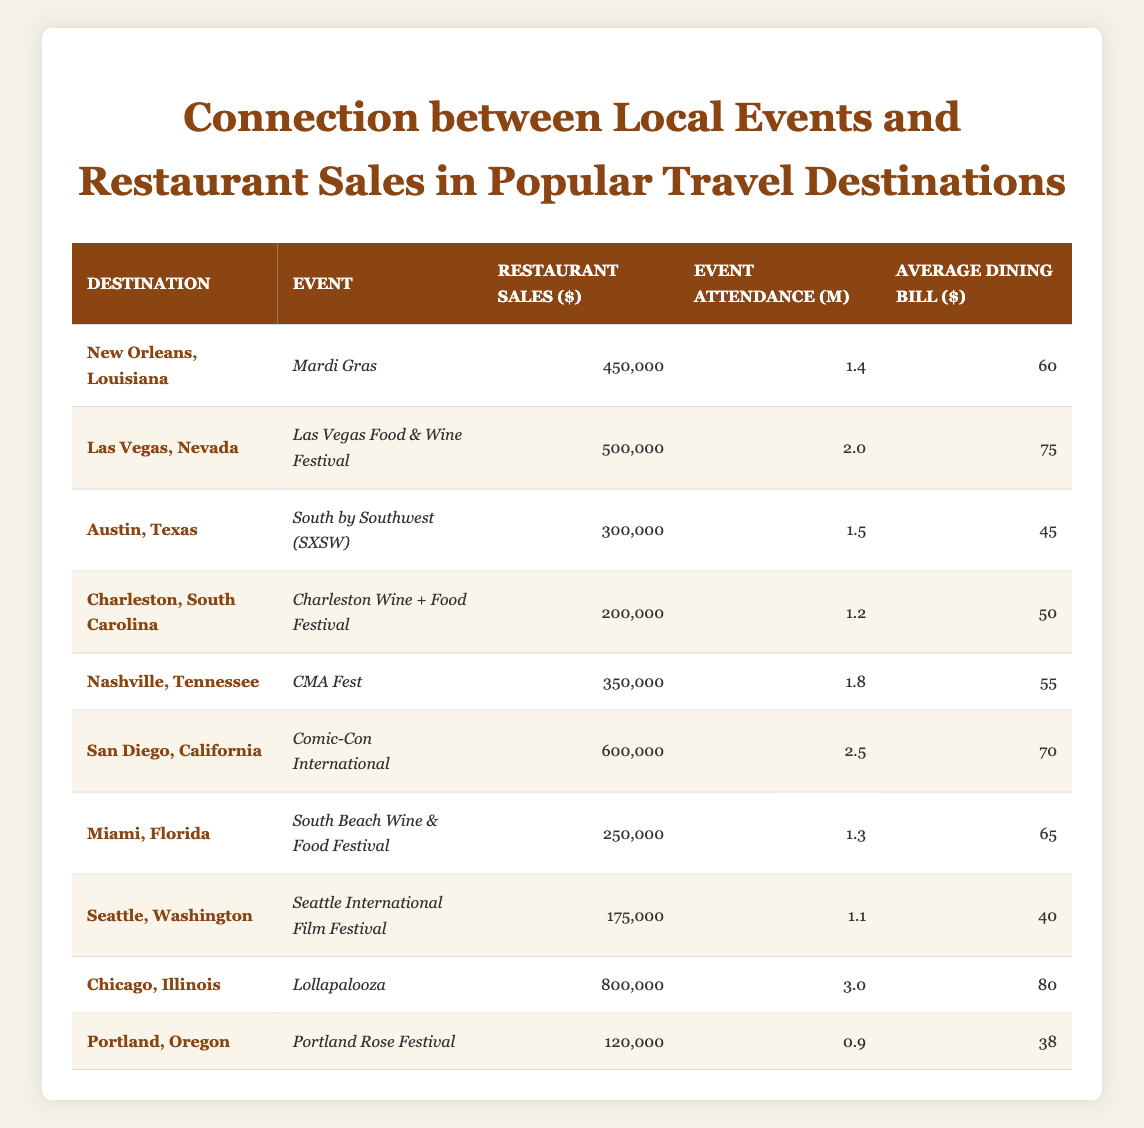What is the highest restaurant sales recorded in the table? By looking at the "Restaurant Sales ($)" column, I compare values and find that Chicago, Illinois has the highest sales at 800,000 dollars.
Answer: 800,000 What is the average event attendance across all destinations? To find the average event attendance, I sum all the attendance values: (1.4 + 2 + 1.5 + 1.2 + 1.8 + 2.5 + 1.3 + 1.1 + 3 + 0.9) = 17.7. Then, I divide by the number of destinations (10). Thus, the average is 17.7 / 10 = 1.77.
Answer: 1.77 Is the average dining bill in Las Vegas higher than in Austin? In the "Average Dining Bill ($)" column, Las Vegas has a bill of 75 dollars, while Austin has a bill of 45 dollars. Since 75 is greater than 45, the statement is true.
Answer: Yes Which destination has the lowest restaurant sales, and what is the amount? By scanning the "Restaurant Sales ($)" column, I see that Portland, Oregon has the lowest sales recorded at 120,000 dollars.
Answer: 120,000 What is the total restaurant sales of destinations that have event attendance over 2? I identify the destinations with attendance over 2: Las Vegas (500,000), San Diego (600,000), and Chicago (800,000). Adding these gives: (500,000 + 600,000 + 800,000) = 1,900,000 dollars.
Answer: 1,900,000 Are there any destinations with restaurant sales below 200,000? Scanning through the "Restaurant Sales ($)" column, I see that both Charleston (200,000) and Portland (120,000) have sales below 200,000 dollars. Thus, the statement is true.
Answer: Yes What is the average restaurant sales for events with attendance less than 1.5? The relevant destinations are Charleston, South Carolina (200,000), Miami, Florida (250,000), and Seattle, Washington (175,000). The total sales for these are (200,000 + 250,000 + 175,000) = 625,000. There are three destinations, so the average is 625,000 / 3 = 208,333.33.
Answer: 208,333.33 Which destination had the highest average dining bill, and what was it? Looking at the "Average Dining Bill ($)" column, I compare values and see that Chicago, Illinois has the highest bill at 80 dollars.
Answer: 80 How many events have restaurant sales greater than 400,000? I inspect the "Restaurant Sales ($)" column for values above 400,000. The events with sales greater than 400,000 are New Orleans (450,000), Las Vegas (500,000), San Diego (600,000), and Chicago (800,000), totaling four events.
Answer: 4 